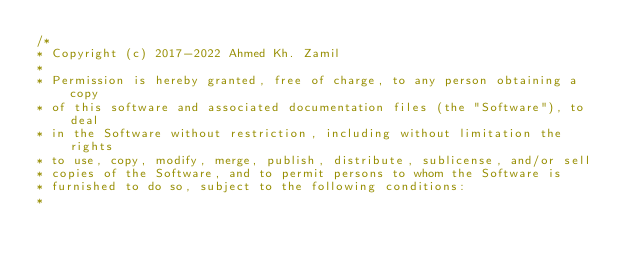Convert code to text. <code><loc_0><loc_0><loc_500><loc_500><_JavaScript_>/*
* Copyright (c) 2017-2022 Ahmed Kh. Zamil
*
* Permission is hereby granted, free of charge, to any person obtaining a copy
* of this software and associated documentation files (the "Software"), to deal
* in the Software without restriction, including without limitation the rights
* to use, copy, modify, merge, publish, distribute, sublicense, and/or sell
* copies of the Software, and to permit persons to whom the Software is
* furnished to do so, subject to the following conditions:
*</code> 